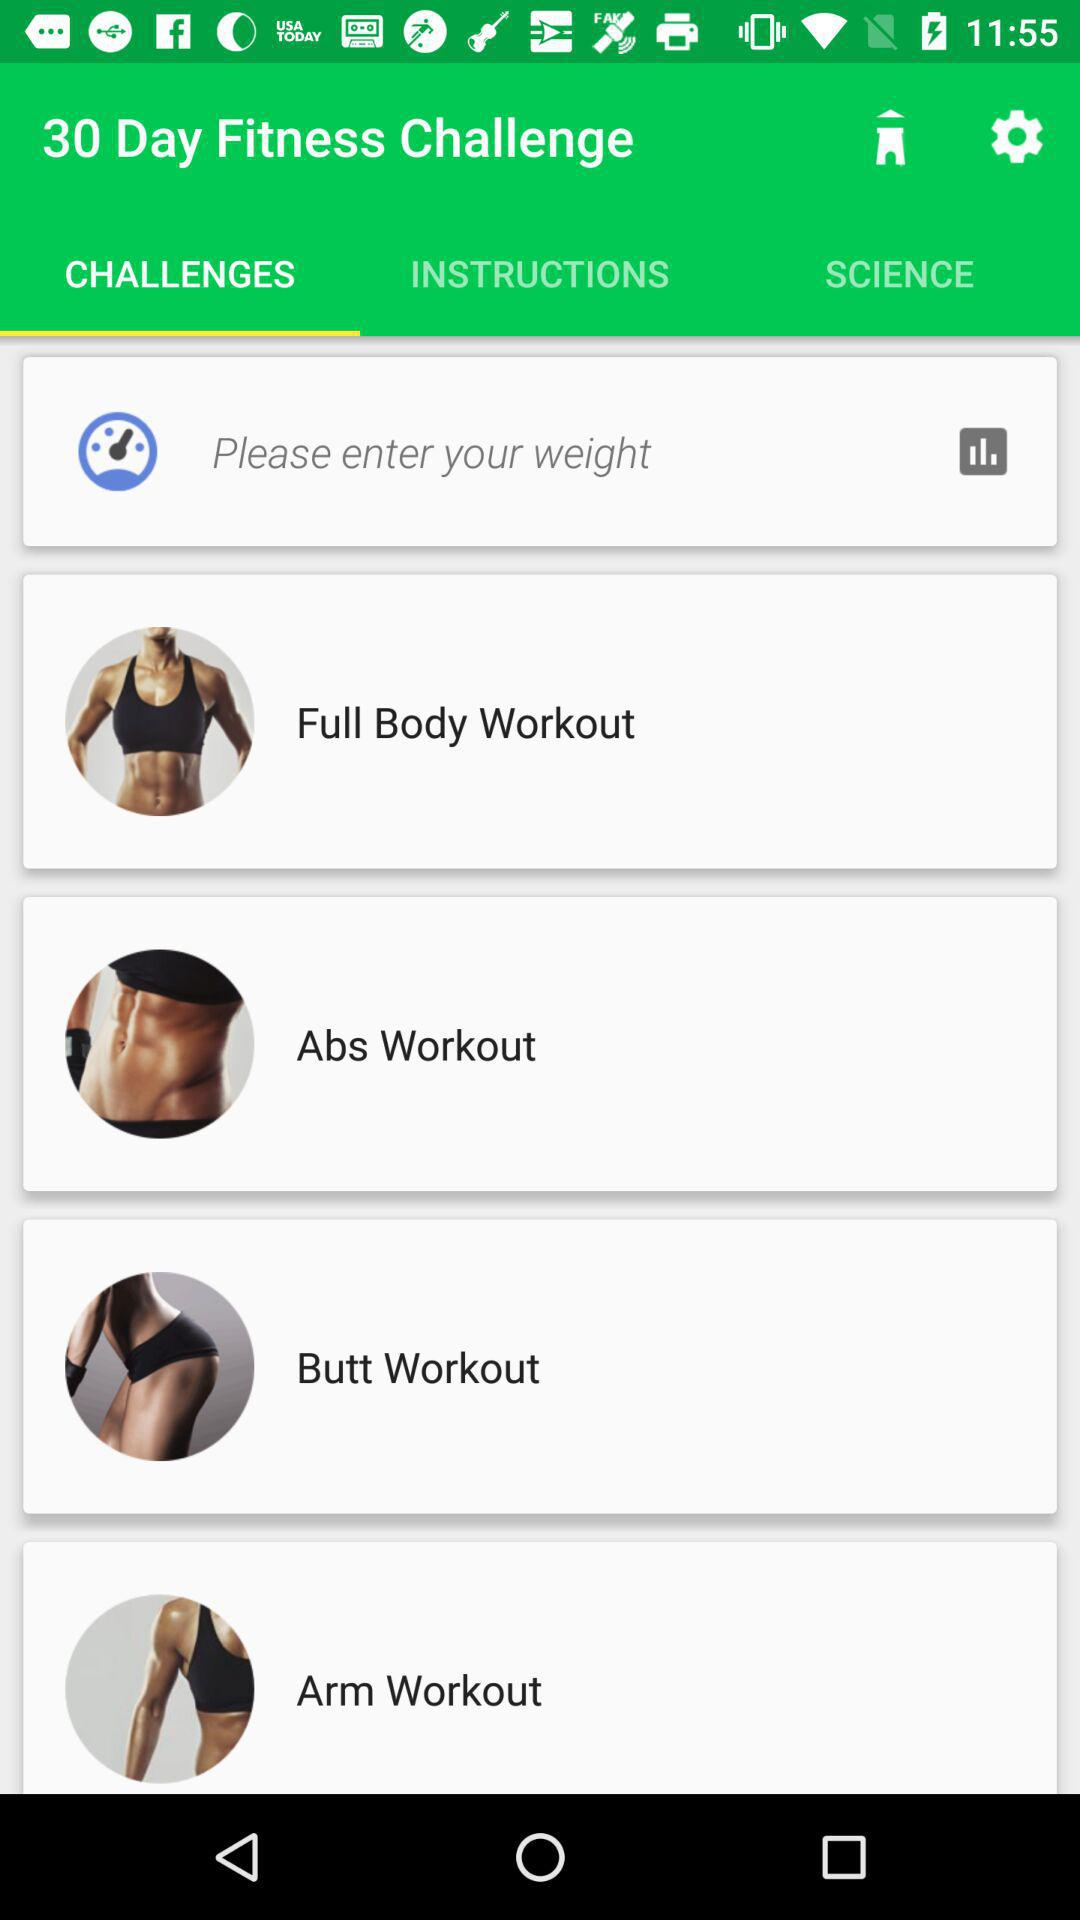How many workouts are there to choose from?
Answer the question using a single word or phrase. 4 